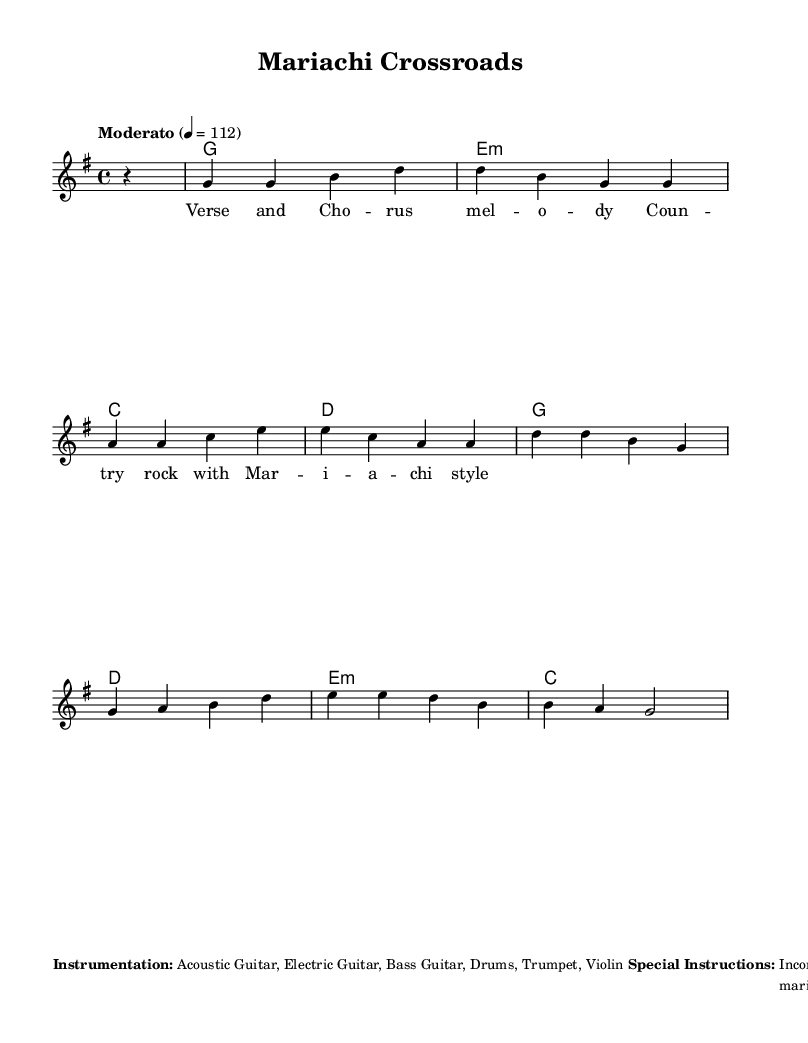What is the key signature of this music? The key signature is G major, which has one sharp (F#). This is indicated before the staff in the music notation.
Answer: G major What is the time signature of this music? The time signature is 4/4, which is shown at the beginning of the staff. This means there are four beats in each measure and the quarter note gets one beat.
Answer: 4/4 What is the tempo marking of this piece? The tempo marking indicates "Moderato" with a metronome marking of 112 beats per minute. This suggests a moderate pace for the piece.
Answer: Moderato 4 = 112 How many measures are in the melody section? The melody section contains 8 measures, as each segment of music between the bar lines counts as one measure. There are 8 groups of notes or rests in total.
Answer: 8 Which instruments are specified for this piece? The instrumentation includes Acoustic Guitar, Electric Guitar, Bass Guitar, Drums, Trumpet, and Violin. This is listed under the special instructions section.
Answer: Acoustic Guitar, Electric Guitar, Bass Guitar, Drums, Trumpet, Violin What strumming pattern is suggested for the acoustic guitar? The suggested strumming pattern for the acoustic guitar is D DU UDU. This describes the down and up strumming motions indicated in the rhythm section.
Answer: D DU UDU What type of rhythm does the drum section follow? The drum section follows a basic country rock beat with occasional mariachi-style fills. This combines traditional country rock rhythms with added flourishes characteristic of mariachi music.
Answer: Basic country rock beat with occasional mariachi-style fills 